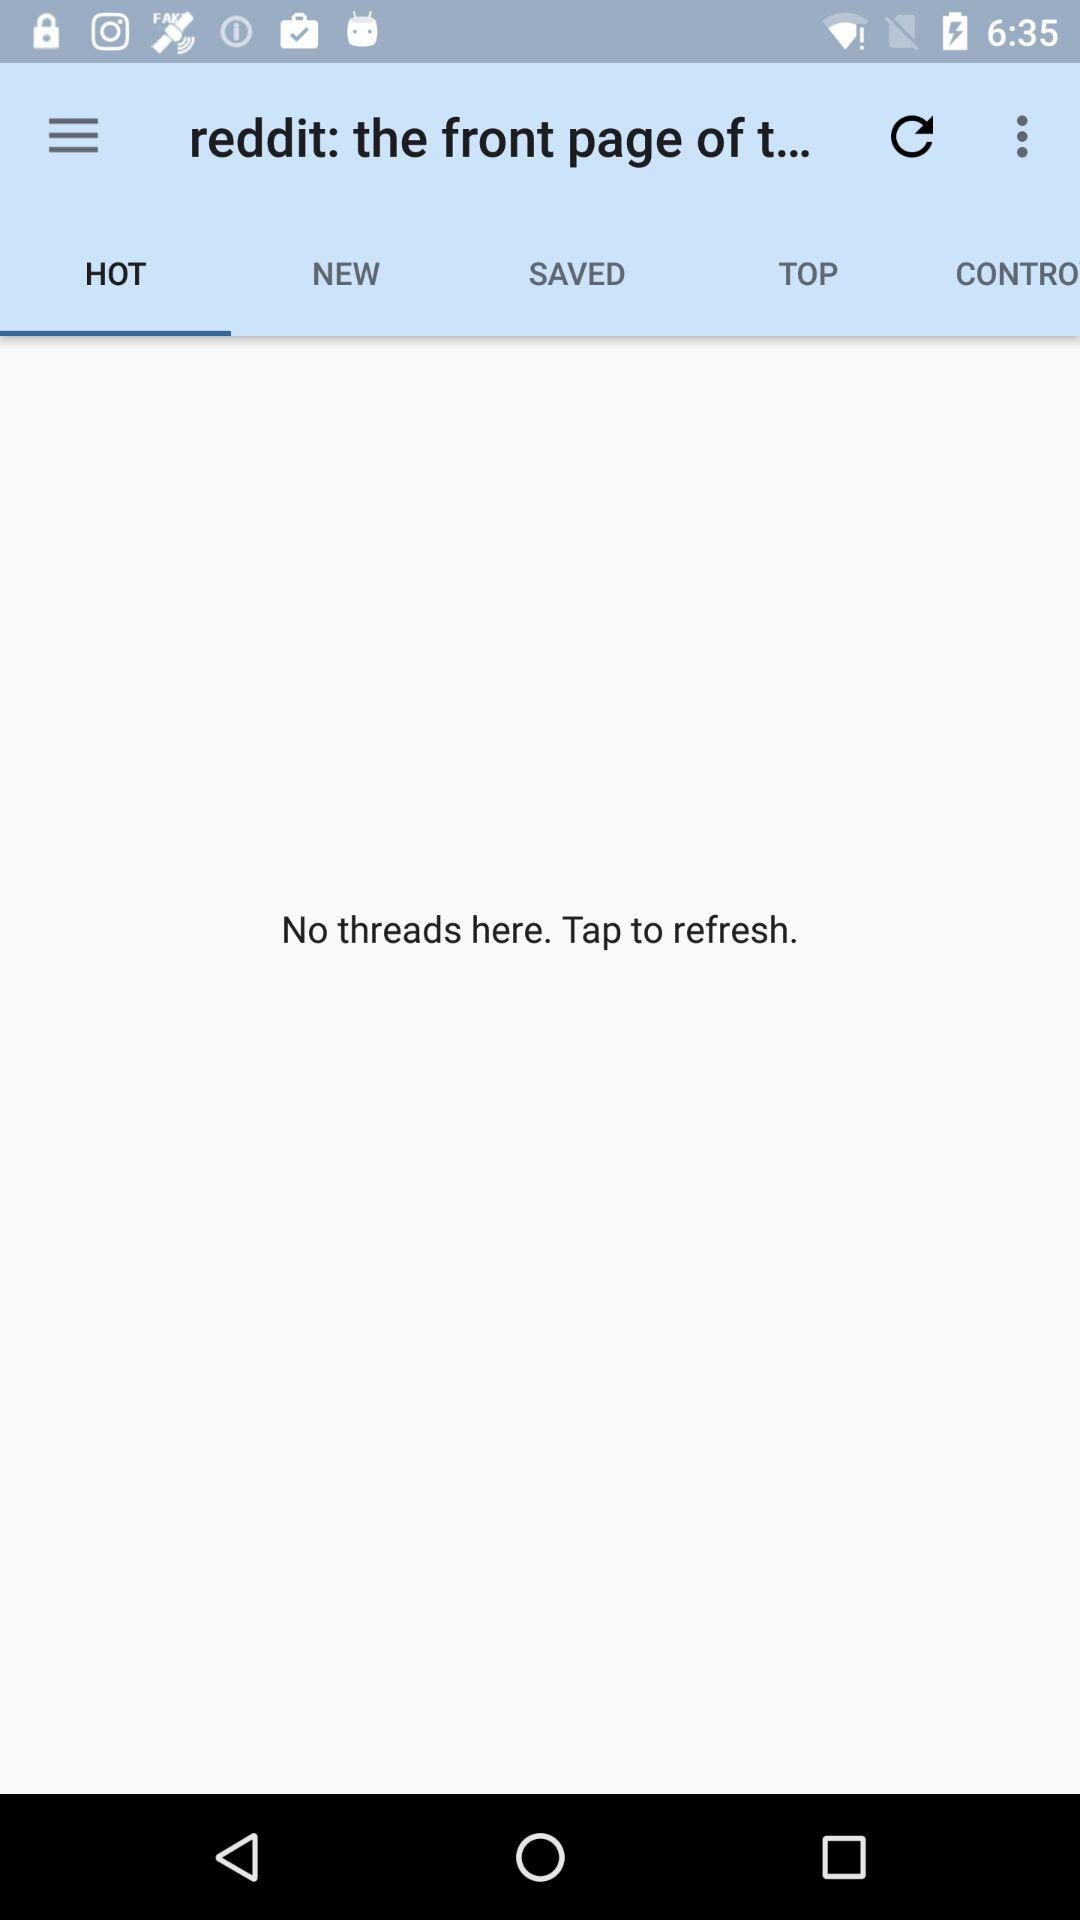Which tab is selected? The selected tab is "HOT". 